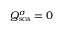Convert formula to latex. <formula><loc_0><loc_0><loc_500><loc_500>Q _ { s c a } ^ { \sigma } = 0</formula> 